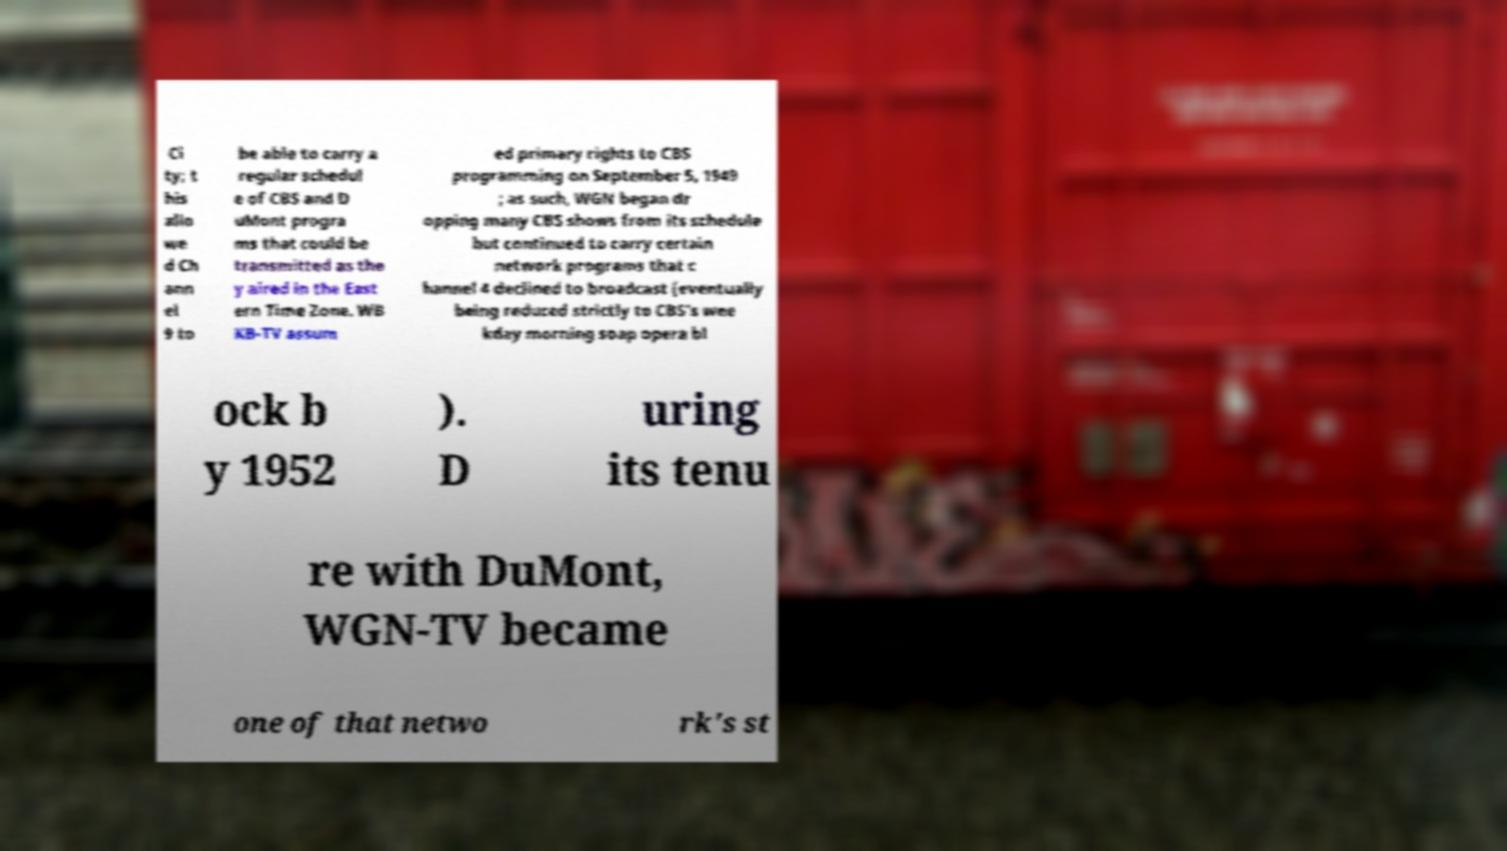Please read and relay the text visible in this image. What does it say? Ci ty; t his allo we d Ch ann el 9 to be able to carry a regular schedul e of CBS and D uMont progra ms that could be transmitted as the y aired in the East ern Time Zone. WB KB-TV assum ed primary rights to CBS programming on September 5, 1949 ; as such, WGN began dr opping many CBS shows from its schedule but continued to carry certain network programs that c hannel 4 declined to broadcast (eventually being reduced strictly to CBS's wee kday morning soap opera bl ock b y 1952 ). D uring its tenu re with DuMont, WGN-TV became one of that netwo rk's st 